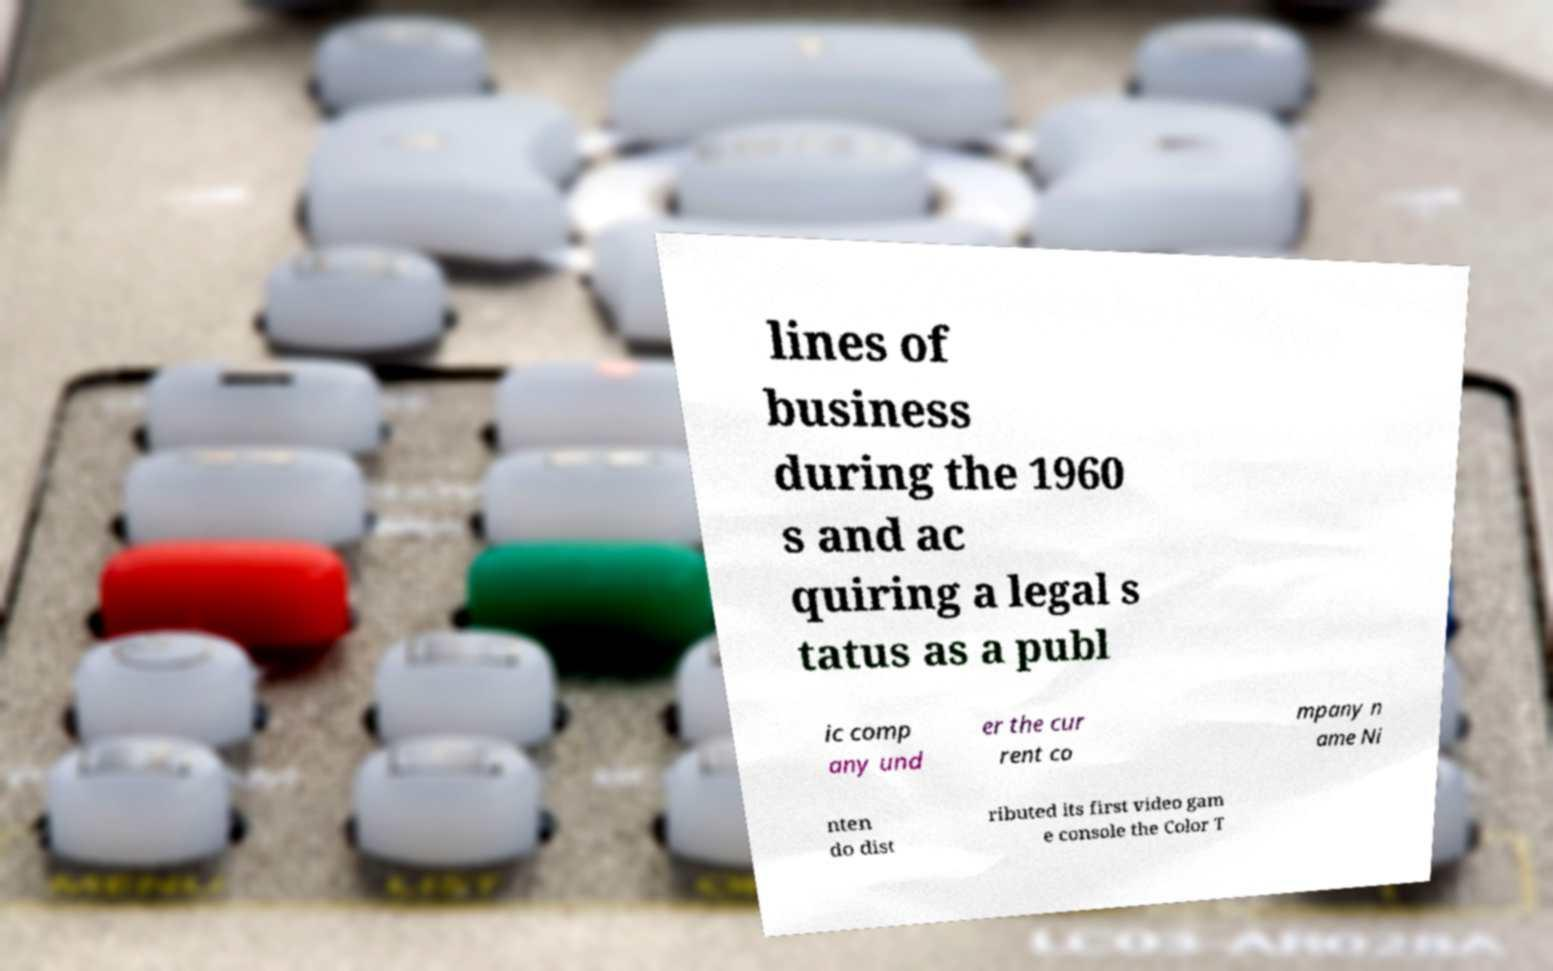Could you extract and type out the text from this image? lines of business during the 1960 s and ac quiring a legal s tatus as a publ ic comp any und er the cur rent co mpany n ame Ni nten do dist ributed its first video gam e console the Color T 